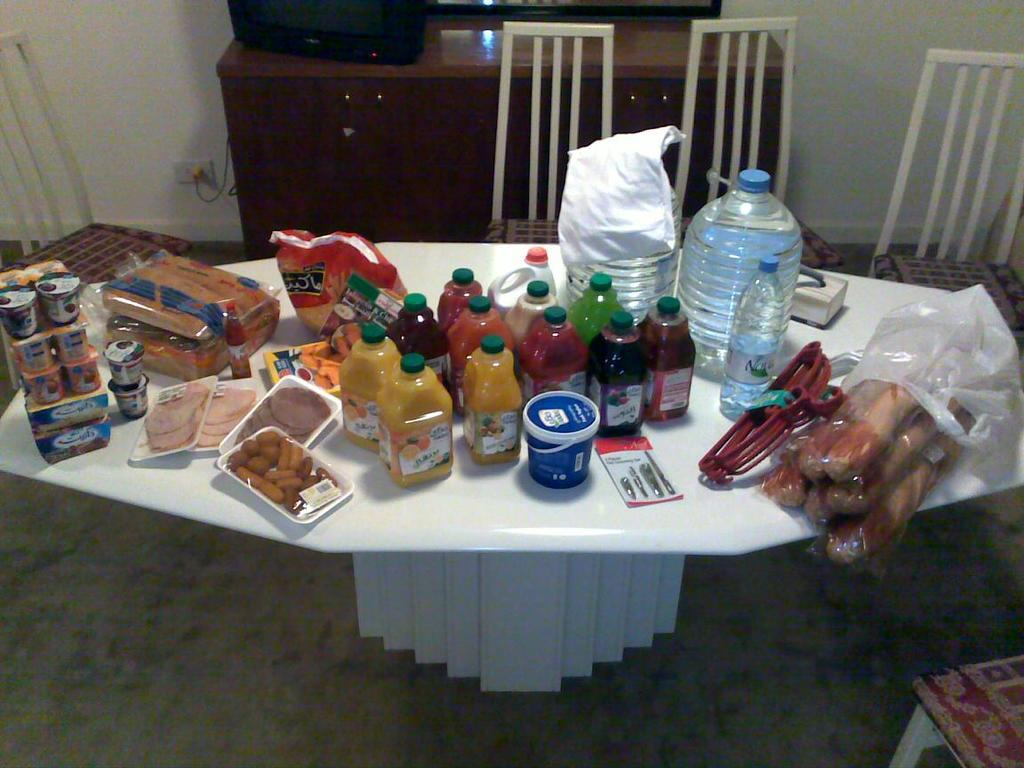What is on the table in the image? There is a bottle and food on the table. What else can be seen on the table? There are hangers on the table. What type of furniture is near the table? Chairs are near the table. What electronic device is present near the table? A television is present near the table. What type of wax can be seen melting on the television in the image? There is no wax present on the television in the image. 